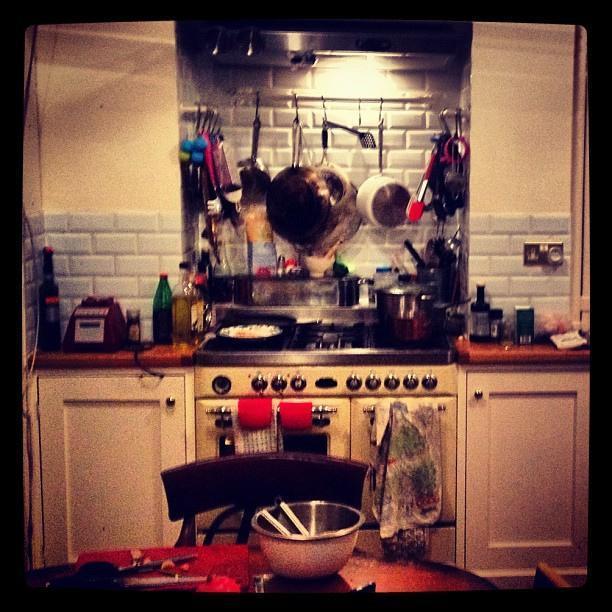How many people holding umbrellas are in the picture?
Give a very brief answer. 0. 